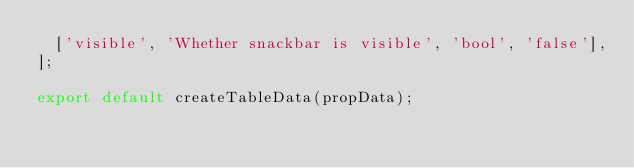<code> <loc_0><loc_0><loc_500><loc_500><_JavaScript_>  ['visible', 'Whether snackbar is visible', 'bool', 'false'],
];

export default createTableData(propData);
</code> 